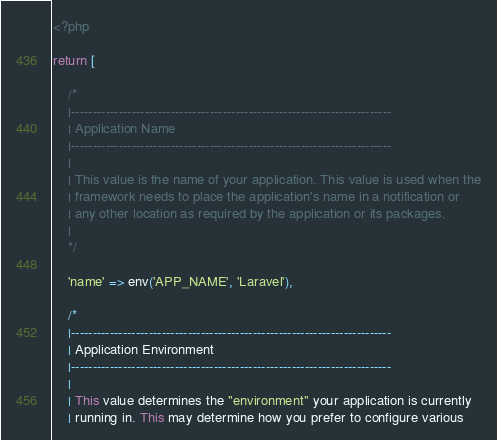<code> <loc_0><loc_0><loc_500><loc_500><_PHP_><?php

return [

    /*
    |--------------------------------------------------------------------------
    | Application Name
    |--------------------------------------------------------------------------
    |
    | This value is the name of your application. This value is used when the
    | framework needs to place the application's name in a notification or
    | any other location as required by the application or its packages.
    |
    */

    'name' => env('APP_NAME', 'Laravel'),

    /*
    |--------------------------------------------------------------------------
    | Application Environment
    |--------------------------------------------------------------------------
    |
    | This value determines the "environment" your application is currently
    | running in. This may determine how you prefer to configure various</code> 